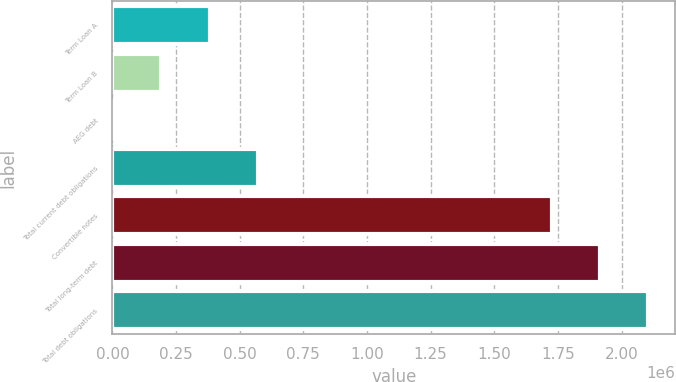Convert chart to OTSL. <chart><loc_0><loc_0><loc_500><loc_500><bar_chart><fcel>Term Loan A<fcel>Term Loan B<fcel>AEG debt<fcel>Total current debt obligations<fcel>Convertible notes<fcel>Total long-term debt<fcel>Total debt obligations<nl><fcel>381866<fcel>191683<fcel>1500<fcel>572048<fcel>1.725e+06<fcel>1.91518e+06<fcel>2.10537e+06<nl></chart> 